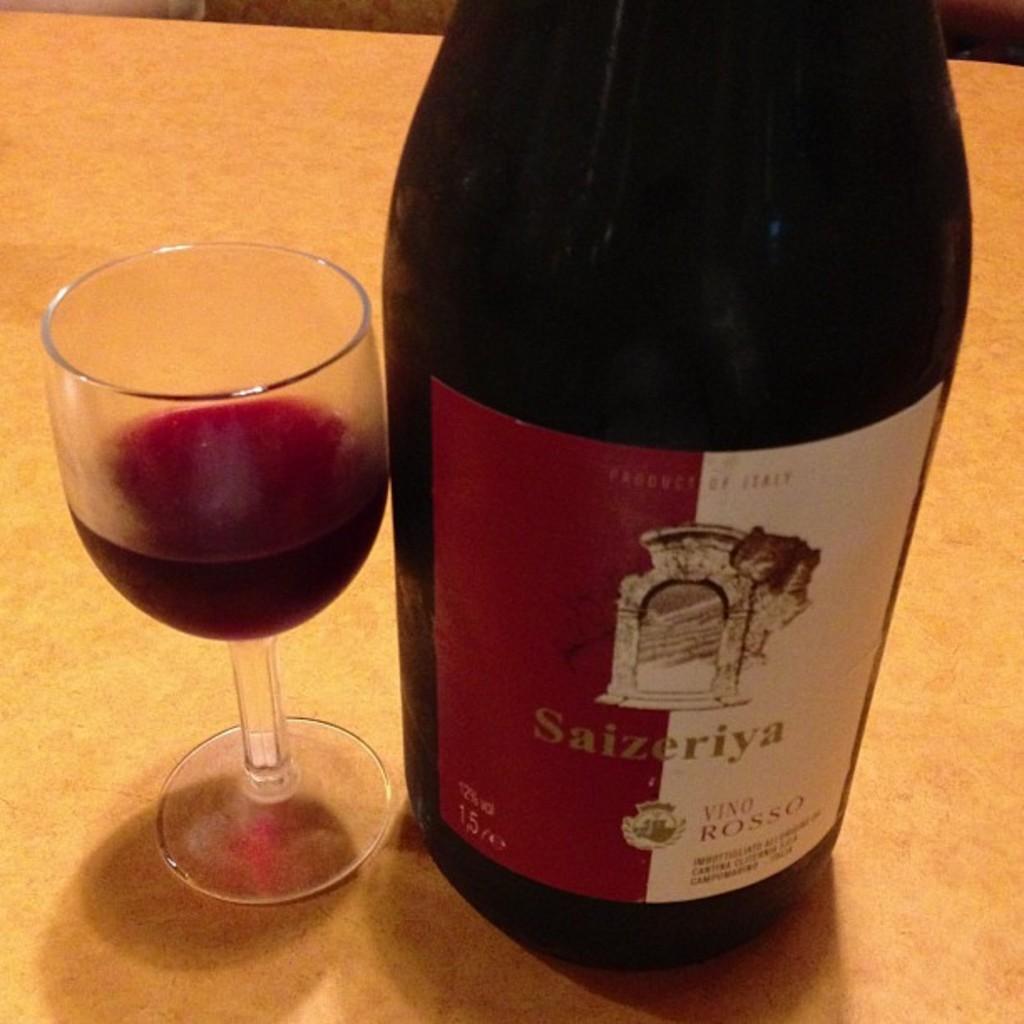Please provide a concise description of this image. In this picture, it looks like a table. On the table there is a glass with some liquid. On the right side of the glass, there is a bottle. 